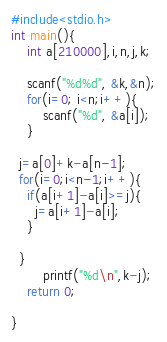Convert code to text. <code><loc_0><loc_0><loc_500><loc_500><_C_>#include<stdio.h>
int main(){
    int a[210000],i,n,j,k;
	
	scanf("%d%d", &k,&n);
	for(i=0; i<n;i++){
		scanf("%d", &a[i]);
	}
  
  j=a[0]+k-a[n-1];
  for(i=0;i<n-1;i++){
    if(a[i+1]-a[i]>=j){
      j=a[i+1]-a[i];
    }

  }
	    printf("%d\n",k-j);
    return 0;
	
}
</code> 